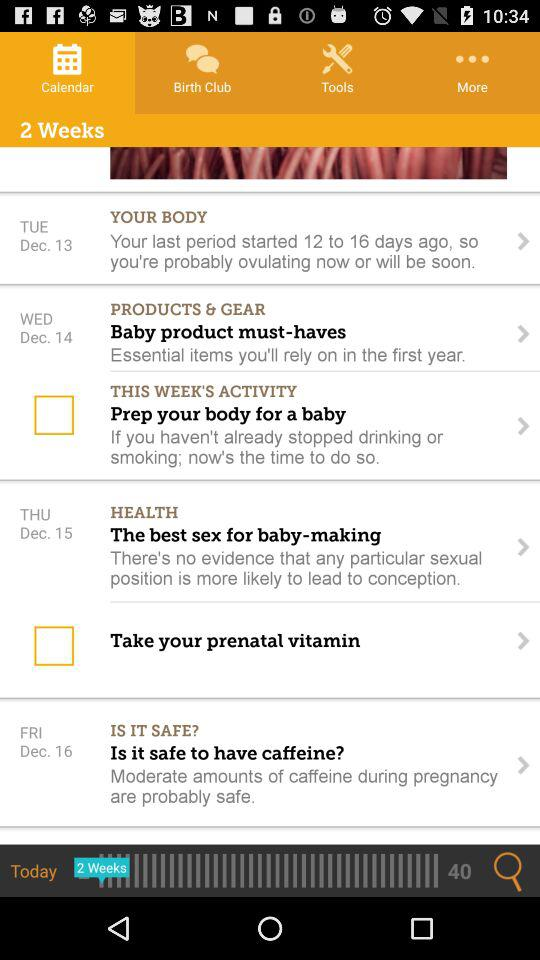What's the date for "Health"? The date is Thursday, December 15. 